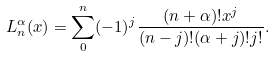<formula> <loc_0><loc_0><loc_500><loc_500>L _ { n } ^ { \alpha } ( x ) = \sum _ { 0 } ^ { n } ( - 1 ) ^ { j } \frac { ( n + \alpha ) ! x ^ { j } } { ( n - j ) ! ( \alpha + j ) ! j ! } .</formula> 